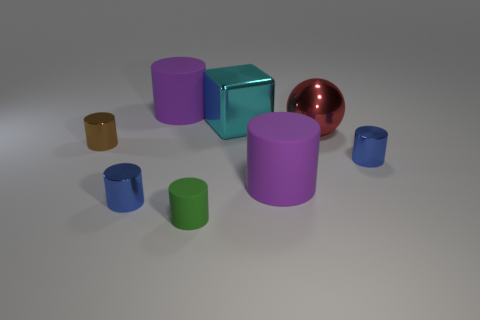What is the material of the green cylinder?
Provide a succinct answer. Rubber. Is there a big thing that has the same material as the large red ball?
Your response must be concise. Yes. How many large purple rubber balls are there?
Ensure brevity in your answer.  0. Is the small green thing made of the same material as the large purple object in front of the brown cylinder?
Your answer should be very brief. Yes. What number of big shiny things are the same color as the big sphere?
Your answer should be very brief. 0. The red metal thing has what size?
Provide a succinct answer. Large. There is a red shiny thing; is it the same shape as the big metal thing that is on the left side of the red shiny sphere?
Keep it short and to the point. No. There is a ball that is made of the same material as the cyan block; what color is it?
Make the answer very short. Red. There is a blue shiny cylinder that is right of the large red metal sphere; how big is it?
Ensure brevity in your answer.  Small. Are there fewer tiny objects that are behind the cyan thing than metallic spheres?
Provide a succinct answer. Yes. 